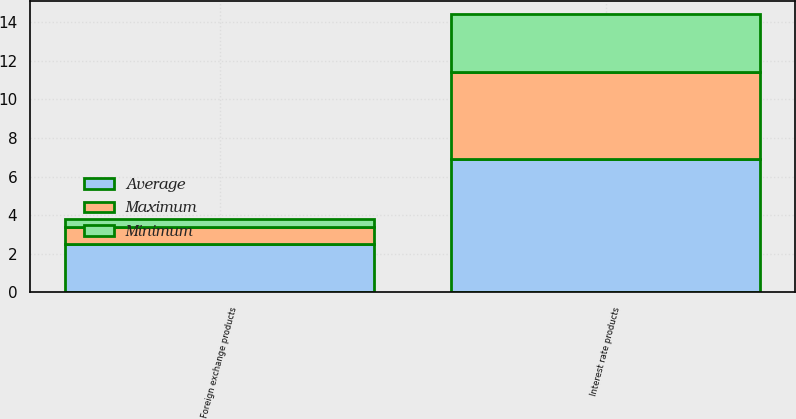<chart> <loc_0><loc_0><loc_500><loc_500><stacked_bar_chart><ecel><fcel>Foreign exchange products<fcel>Interest rate products<nl><fcel>Maximum<fcel>0.9<fcel>4.5<nl><fcel>Average<fcel>2.5<fcel>6.9<nl><fcel>Minimum<fcel>0.4<fcel>3<nl></chart> 